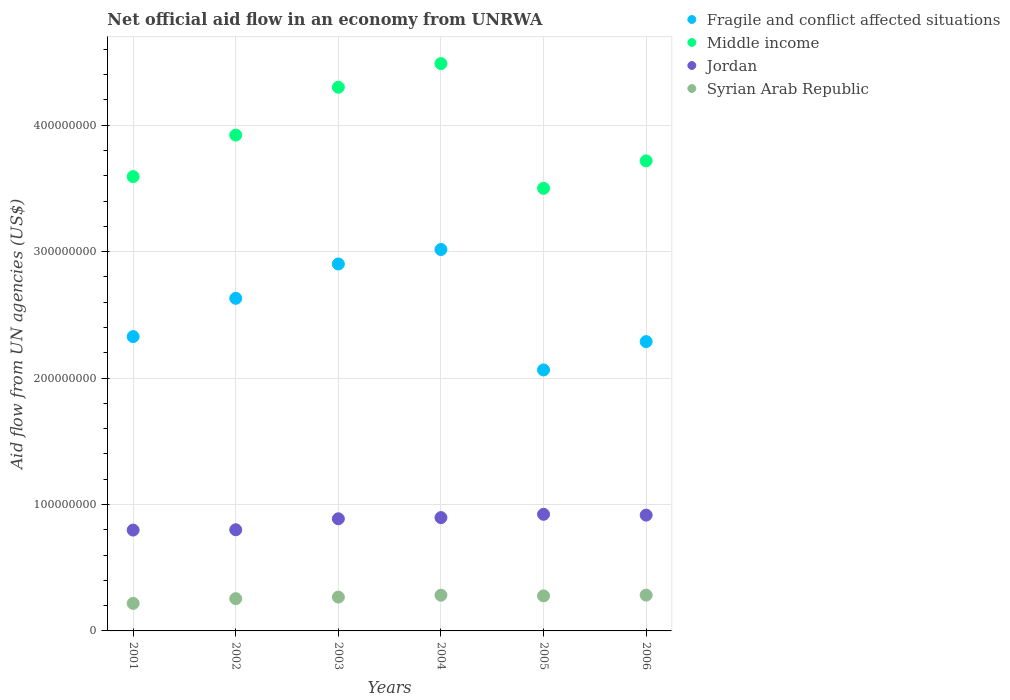How many different coloured dotlines are there?
Give a very brief answer. 4. Is the number of dotlines equal to the number of legend labels?
Give a very brief answer. Yes. What is the net official aid flow in Fragile and conflict affected situations in 2006?
Keep it short and to the point. 2.29e+08. Across all years, what is the maximum net official aid flow in Jordan?
Provide a short and direct response. 9.22e+07. Across all years, what is the minimum net official aid flow in Middle income?
Provide a succinct answer. 3.50e+08. What is the total net official aid flow in Fragile and conflict affected situations in the graph?
Offer a very short reply. 1.52e+09. What is the difference between the net official aid flow in Jordan in 2002 and that in 2006?
Offer a terse response. -1.16e+07. What is the difference between the net official aid flow in Syrian Arab Republic in 2004 and the net official aid flow in Jordan in 2005?
Offer a very short reply. -6.40e+07. What is the average net official aid flow in Fragile and conflict affected situations per year?
Make the answer very short. 2.54e+08. In the year 2004, what is the difference between the net official aid flow in Fragile and conflict affected situations and net official aid flow in Syrian Arab Republic?
Provide a short and direct response. 2.73e+08. In how many years, is the net official aid flow in Fragile and conflict affected situations greater than 180000000 US$?
Provide a short and direct response. 6. What is the ratio of the net official aid flow in Fragile and conflict affected situations in 2001 to that in 2003?
Offer a terse response. 0.8. Is the difference between the net official aid flow in Fragile and conflict affected situations in 2005 and 2006 greater than the difference between the net official aid flow in Syrian Arab Republic in 2005 and 2006?
Give a very brief answer. No. What is the difference between the highest and the second highest net official aid flow in Fragile and conflict affected situations?
Offer a very short reply. 1.15e+07. What is the difference between the highest and the lowest net official aid flow in Fragile and conflict affected situations?
Offer a terse response. 9.53e+07. In how many years, is the net official aid flow in Fragile and conflict affected situations greater than the average net official aid flow in Fragile and conflict affected situations taken over all years?
Your answer should be very brief. 3. Is the sum of the net official aid flow in Syrian Arab Republic in 2004 and 2006 greater than the maximum net official aid flow in Jordan across all years?
Keep it short and to the point. No. Is it the case that in every year, the sum of the net official aid flow in Syrian Arab Republic and net official aid flow in Fragile and conflict affected situations  is greater than the sum of net official aid flow in Jordan and net official aid flow in Middle income?
Provide a succinct answer. Yes. Does the net official aid flow in Middle income monotonically increase over the years?
Give a very brief answer. No. Is the net official aid flow in Syrian Arab Republic strictly less than the net official aid flow in Jordan over the years?
Provide a short and direct response. Yes. How many dotlines are there?
Make the answer very short. 4. How many years are there in the graph?
Offer a very short reply. 6. What is the difference between two consecutive major ticks on the Y-axis?
Keep it short and to the point. 1.00e+08. Are the values on the major ticks of Y-axis written in scientific E-notation?
Your answer should be very brief. No. Does the graph contain any zero values?
Ensure brevity in your answer.  No. Does the graph contain grids?
Keep it short and to the point. Yes. How are the legend labels stacked?
Your response must be concise. Vertical. What is the title of the graph?
Make the answer very short. Net official aid flow in an economy from UNRWA. Does "Northern Mariana Islands" appear as one of the legend labels in the graph?
Give a very brief answer. No. What is the label or title of the Y-axis?
Your answer should be compact. Aid flow from UN agencies (US$). What is the Aid flow from UN agencies (US$) of Fragile and conflict affected situations in 2001?
Give a very brief answer. 2.33e+08. What is the Aid flow from UN agencies (US$) of Middle income in 2001?
Ensure brevity in your answer.  3.59e+08. What is the Aid flow from UN agencies (US$) in Jordan in 2001?
Give a very brief answer. 7.98e+07. What is the Aid flow from UN agencies (US$) of Syrian Arab Republic in 2001?
Your response must be concise. 2.18e+07. What is the Aid flow from UN agencies (US$) of Fragile and conflict affected situations in 2002?
Give a very brief answer. 2.63e+08. What is the Aid flow from UN agencies (US$) in Middle income in 2002?
Your answer should be very brief. 3.92e+08. What is the Aid flow from UN agencies (US$) of Jordan in 2002?
Make the answer very short. 8.00e+07. What is the Aid flow from UN agencies (US$) of Syrian Arab Republic in 2002?
Ensure brevity in your answer.  2.55e+07. What is the Aid flow from UN agencies (US$) in Fragile and conflict affected situations in 2003?
Keep it short and to the point. 2.90e+08. What is the Aid flow from UN agencies (US$) in Middle income in 2003?
Provide a succinct answer. 4.30e+08. What is the Aid flow from UN agencies (US$) in Jordan in 2003?
Your response must be concise. 8.87e+07. What is the Aid flow from UN agencies (US$) in Syrian Arab Republic in 2003?
Make the answer very short. 2.68e+07. What is the Aid flow from UN agencies (US$) of Fragile and conflict affected situations in 2004?
Your answer should be very brief. 3.02e+08. What is the Aid flow from UN agencies (US$) in Middle income in 2004?
Give a very brief answer. 4.49e+08. What is the Aid flow from UN agencies (US$) of Jordan in 2004?
Make the answer very short. 8.96e+07. What is the Aid flow from UN agencies (US$) in Syrian Arab Republic in 2004?
Offer a very short reply. 2.83e+07. What is the Aid flow from UN agencies (US$) in Fragile and conflict affected situations in 2005?
Your answer should be very brief. 2.06e+08. What is the Aid flow from UN agencies (US$) in Middle income in 2005?
Offer a very short reply. 3.50e+08. What is the Aid flow from UN agencies (US$) in Jordan in 2005?
Provide a short and direct response. 9.22e+07. What is the Aid flow from UN agencies (US$) in Syrian Arab Republic in 2005?
Provide a succinct answer. 2.77e+07. What is the Aid flow from UN agencies (US$) of Fragile and conflict affected situations in 2006?
Your answer should be very brief. 2.29e+08. What is the Aid flow from UN agencies (US$) in Middle income in 2006?
Your answer should be compact. 3.72e+08. What is the Aid flow from UN agencies (US$) of Jordan in 2006?
Make the answer very short. 9.16e+07. What is the Aid flow from UN agencies (US$) in Syrian Arab Republic in 2006?
Offer a very short reply. 2.83e+07. Across all years, what is the maximum Aid flow from UN agencies (US$) in Fragile and conflict affected situations?
Make the answer very short. 3.02e+08. Across all years, what is the maximum Aid flow from UN agencies (US$) in Middle income?
Make the answer very short. 4.49e+08. Across all years, what is the maximum Aid flow from UN agencies (US$) in Jordan?
Give a very brief answer. 9.22e+07. Across all years, what is the maximum Aid flow from UN agencies (US$) in Syrian Arab Republic?
Make the answer very short. 2.83e+07. Across all years, what is the minimum Aid flow from UN agencies (US$) in Fragile and conflict affected situations?
Ensure brevity in your answer.  2.06e+08. Across all years, what is the minimum Aid flow from UN agencies (US$) of Middle income?
Offer a terse response. 3.50e+08. Across all years, what is the minimum Aid flow from UN agencies (US$) in Jordan?
Ensure brevity in your answer.  7.98e+07. Across all years, what is the minimum Aid flow from UN agencies (US$) of Syrian Arab Republic?
Ensure brevity in your answer.  2.18e+07. What is the total Aid flow from UN agencies (US$) of Fragile and conflict affected situations in the graph?
Provide a succinct answer. 1.52e+09. What is the total Aid flow from UN agencies (US$) of Middle income in the graph?
Give a very brief answer. 2.35e+09. What is the total Aid flow from UN agencies (US$) in Jordan in the graph?
Your answer should be very brief. 5.22e+08. What is the total Aid flow from UN agencies (US$) of Syrian Arab Republic in the graph?
Ensure brevity in your answer.  1.58e+08. What is the difference between the Aid flow from UN agencies (US$) of Fragile and conflict affected situations in 2001 and that in 2002?
Your answer should be very brief. -3.03e+07. What is the difference between the Aid flow from UN agencies (US$) of Middle income in 2001 and that in 2002?
Offer a terse response. -3.28e+07. What is the difference between the Aid flow from UN agencies (US$) in Syrian Arab Republic in 2001 and that in 2002?
Offer a terse response. -3.75e+06. What is the difference between the Aid flow from UN agencies (US$) in Fragile and conflict affected situations in 2001 and that in 2003?
Keep it short and to the point. -5.74e+07. What is the difference between the Aid flow from UN agencies (US$) of Middle income in 2001 and that in 2003?
Make the answer very short. -7.07e+07. What is the difference between the Aid flow from UN agencies (US$) of Jordan in 2001 and that in 2003?
Your answer should be very brief. -8.93e+06. What is the difference between the Aid flow from UN agencies (US$) in Syrian Arab Republic in 2001 and that in 2003?
Provide a short and direct response. -4.99e+06. What is the difference between the Aid flow from UN agencies (US$) of Fragile and conflict affected situations in 2001 and that in 2004?
Offer a terse response. -6.89e+07. What is the difference between the Aid flow from UN agencies (US$) in Middle income in 2001 and that in 2004?
Provide a succinct answer. -8.94e+07. What is the difference between the Aid flow from UN agencies (US$) in Jordan in 2001 and that in 2004?
Your response must be concise. -9.87e+06. What is the difference between the Aid flow from UN agencies (US$) of Syrian Arab Republic in 2001 and that in 2004?
Provide a short and direct response. -6.48e+06. What is the difference between the Aid flow from UN agencies (US$) in Fragile and conflict affected situations in 2001 and that in 2005?
Your response must be concise. 2.64e+07. What is the difference between the Aid flow from UN agencies (US$) in Middle income in 2001 and that in 2005?
Ensure brevity in your answer.  9.26e+06. What is the difference between the Aid flow from UN agencies (US$) in Jordan in 2001 and that in 2005?
Give a very brief answer. -1.25e+07. What is the difference between the Aid flow from UN agencies (US$) of Syrian Arab Republic in 2001 and that in 2005?
Your response must be concise. -5.93e+06. What is the difference between the Aid flow from UN agencies (US$) in Fragile and conflict affected situations in 2001 and that in 2006?
Offer a terse response. 3.96e+06. What is the difference between the Aid flow from UN agencies (US$) of Middle income in 2001 and that in 2006?
Your response must be concise. -1.24e+07. What is the difference between the Aid flow from UN agencies (US$) of Jordan in 2001 and that in 2006?
Keep it short and to the point. -1.18e+07. What is the difference between the Aid flow from UN agencies (US$) of Syrian Arab Republic in 2001 and that in 2006?
Your answer should be very brief. -6.54e+06. What is the difference between the Aid flow from UN agencies (US$) of Fragile and conflict affected situations in 2002 and that in 2003?
Your response must be concise. -2.72e+07. What is the difference between the Aid flow from UN agencies (US$) in Middle income in 2002 and that in 2003?
Keep it short and to the point. -3.79e+07. What is the difference between the Aid flow from UN agencies (US$) of Jordan in 2002 and that in 2003?
Keep it short and to the point. -8.69e+06. What is the difference between the Aid flow from UN agencies (US$) of Syrian Arab Republic in 2002 and that in 2003?
Offer a very short reply. -1.24e+06. What is the difference between the Aid flow from UN agencies (US$) in Fragile and conflict affected situations in 2002 and that in 2004?
Offer a terse response. -3.86e+07. What is the difference between the Aid flow from UN agencies (US$) of Middle income in 2002 and that in 2004?
Provide a short and direct response. -5.66e+07. What is the difference between the Aid flow from UN agencies (US$) in Jordan in 2002 and that in 2004?
Your answer should be compact. -9.63e+06. What is the difference between the Aid flow from UN agencies (US$) of Syrian Arab Republic in 2002 and that in 2004?
Offer a terse response. -2.73e+06. What is the difference between the Aid flow from UN agencies (US$) in Fragile and conflict affected situations in 2002 and that in 2005?
Make the answer very short. 5.67e+07. What is the difference between the Aid flow from UN agencies (US$) of Middle income in 2002 and that in 2005?
Offer a very short reply. 4.21e+07. What is the difference between the Aid flow from UN agencies (US$) of Jordan in 2002 and that in 2005?
Offer a very short reply. -1.22e+07. What is the difference between the Aid flow from UN agencies (US$) in Syrian Arab Republic in 2002 and that in 2005?
Offer a terse response. -2.18e+06. What is the difference between the Aid flow from UN agencies (US$) in Fragile and conflict affected situations in 2002 and that in 2006?
Give a very brief answer. 3.42e+07. What is the difference between the Aid flow from UN agencies (US$) in Middle income in 2002 and that in 2006?
Keep it short and to the point. 2.04e+07. What is the difference between the Aid flow from UN agencies (US$) in Jordan in 2002 and that in 2006?
Your response must be concise. -1.16e+07. What is the difference between the Aid flow from UN agencies (US$) in Syrian Arab Republic in 2002 and that in 2006?
Give a very brief answer. -2.79e+06. What is the difference between the Aid flow from UN agencies (US$) of Fragile and conflict affected situations in 2003 and that in 2004?
Give a very brief answer. -1.15e+07. What is the difference between the Aid flow from UN agencies (US$) in Middle income in 2003 and that in 2004?
Provide a succinct answer. -1.87e+07. What is the difference between the Aid flow from UN agencies (US$) of Jordan in 2003 and that in 2004?
Provide a succinct answer. -9.40e+05. What is the difference between the Aid flow from UN agencies (US$) of Syrian Arab Republic in 2003 and that in 2004?
Ensure brevity in your answer.  -1.49e+06. What is the difference between the Aid flow from UN agencies (US$) of Fragile and conflict affected situations in 2003 and that in 2005?
Provide a succinct answer. 8.38e+07. What is the difference between the Aid flow from UN agencies (US$) of Middle income in 2003 and that in 2005?
Offer a very short reply. 8.00e+07. What is the difference between the Aid flow from UN agencies (US$) in Jordan in 2003 and that in 2005?
Make the answer very short. -3.55e+06. What is the difference between the Aid flow from UN agencies (US$) in Syrian Arab Republic in 2003 and that in 2005?
Keep it short and to the point. -9.40e+05. What is the difference between the Aid flow from UN agencies (US$) of Fragile and conflict affected situations in 2003 and that in 2006?
Provide a short and direct response. 6.14e+07. What is the difference between the Aid flow from UN agencies (US$) in Middle income in 2003 and that in 2006?
Keep it short and to the point. 5.82e+07. What is the difference between the Aid flow from UN agencies (US$) in Jordan in 2003 and that in 2006?
Give a very brief answer. -2.90e+06. What is the difference between the Aid flow from UN agencies (US$) in Syrian Arab Republic in 2003 and that in 2006?
Your response must be concise. -1.55e+06. What is the difference between the Aid flow from UN agencies (US$) of Fragile and conflict affected situations in 2004 and that in 2005?
Provide a short and direct response. 9.53e+07. What is the difference between the Aid flow from UN agencies (US$) of Middle income in 2004 and that in 2005?
Your answer should be compact. 9.87e+07. What is the difference between the Aid flow from UN agencies (US$) in Jordan in 2004 and that in 2005?
Your answer should be very brief. -2.61e+06. What is the difference between the Aid flow from UN agencies (US$) of Syrian Arab Republic in 2004 and that in 2005?
Your response must be concise. 5.50e+05. What is the difference between the Aid flow from UN agencies (US$) of Fragile and conflict affected situations in 2004 and that in 2006?
Ensure brevity in your answer.  7.29e+07. What is the difference between the Aid flow from UN agencies (US$) in Middle income in 2004 and that in 2006?
Ensure brevity in your answer.  7.70e+07. What is the difference between the Aid flow from UN agencies (US$) in Jordan in 2004 and that in 2006?
Your answer should be compact. -1.96e+06. What is the difference between the Aid flow from UN agencies (US$) in Fragile and conflict affected situations in 2005 and that in 2006?
Give a very brief answer. -2.24e+07. What is the difference between the Aid flow from UN agencies (US$) of Middle income in 2005 and that in 2006?
Provide a short and direct response. -2.17e+07. What is the difference between the Aid flow from UN agencies (US$) in Jordan in 2005 and that in 2006?
Provide a short and direct response. 6.50e+05. What is the difference between the Aid flow from UN agencies (US$) of Syrian Arab Republic in 2005 and that in 2006?
Offer a very short reply. -6.10e+05. What is the difference between the Aid flow from UN agencies (US$) in Fragile and conflict affected situations in 2001 and the Aid flow from UN agencies (US$) in Middle income in 2002?
Your response must be concise. -1.59e+08. What is the difference between the Aid flow from UN agencies (US$) of Fragile and conflict affected situations in 2001 and the Aid flow from UN agencies (US$) of Jordan in 2002?
Give a very brief answer. 1.53e+08. What is the difference between the Aid flow from UN agencies (US$) in Fragile and conflict affected situations in 2001 and the Aid flow from UN agencies (US$) in Syrian Arab Republic in 2002?
Your answer should be very brief. 2.07e+08. What is the difference between the Aid flow from UN agencies (US$) of Middle income in 2001 and the Aid flow from UN agencies (US$) of Jordan in 2002?
Your response must be concise. 2.79e+08. What is the difference between the Aid flow from UN agencies (US$) of Middle income in 2001 and the Aid flow from UN agencies (US$) of Syrian Arab Republic in 2002?
Your answer should be compact. 3.34e+08. What is the difference between the Aid flow from UN agencies (US$) of Jordan in 2001 and the Aid flow from UN agencies (US$) of Syrian Arab Republic in 2002?
Provide a short and direct response. 5.42e+07. What is the difference between the Aid flow from UN agencies (US$) of Fragile and conflict affected situations in 2001 and the Aid flow from UN agencies (US$) of Middle income in 2003?
Your response must be concise. -1.97e+08. What is the difference between the Aid flow from UN agencies (US$) of Fragile and conflict affected situations in 2001 and the Aid flow from UN agencies (US$) of Jordan in 2003?
Offer a very short reply. 1.44e+08. What is the difference between the Aid flow from UN agencies (US$) of Fragile and conflict affected situations in 2001 and the Aid flow from UN agencies (US$) of Syrian Arab Republic in 2003?
Give a very brief answer. 2.06e+08. What is the difference between the Aid flow from UN agencies (US$) of Middle income in 2001 and the Aid flow from UN agencies (US$) of Jordan in 2003?
Offer a very short reply. 2.71e+08. What is the difference between the Aid flow from UN agencies (US$) of Middle income in 2001 and the Aid flow from UN agencies (US$) of Syrian Arab Republic in 2003?
Provide a short and direct response. 3.33e+08. What is the difference between the Aid flow from UN agencies (US$) of Jordan in 2001 and the Aid flow from UN agencies (US$) of Syrian Arab Republic in 2003?
Ensure brevity in your answer.  5.30e+07. What is the difference between the Aid flow from UN agencies (US$) in Fragile and conflict affected situations in 2001 and the Aid flow from UN agencies (US$) in Middle income in 2004?
Offer a very short reply. -2.16e+08. What is the difference between the Aid flow from UN agencies (US$) of Fragile and conflict affected situations in 2001 and the Aid flow from UN agencies (US$) of Jordan in 2004?
Your response must be concise. 1.43e+08. What is the difference between the Aid flow from UN agencies (US$) in Fragile and conflict affected situations in 2001 and the Aid flow from UN agencies (US$) in Syrian Arab Republic in 2004?
Make the answer very short. 2.05e+08. What is the difference between the Aid flow from UN agencies (US$) in Middle income in 2001 and the Aid flow from UN agencies (US$) in Jordan in 2004?
Provide a short and direct response. 2.70e+08. What is the difference between the Aid flow from UN agencies (US$) of Middle income in 2001 and the Aid flow from UN agencies (US$) of Syrian Arab Republic in 2004?
Offer a terse response. 3.31e+08. What is the difference between the Aid flow from UN agencies (US$) of Jordan in 2001 and the Aid flow from UN agencies (US$) of Syrian Arab Republic in 2004?
Offer a very short reply. 5.15e+07. What is the difference between the Aid flow from UN agencies (US$) of Fragile and conflict affected situations in 2001 and the Aid flow from UN agencies (US$) of Middle income in 2005?
Ensure brevity in your answer.  -1.17e+08. What is the difference between the Aid flow from UN agencies (US$) of Fragile and conflict affected situations in 2001 and the Aid flow from UN agencies (US$) of Jordan in 2005?
Your answer should be very brief. 1.41e+08. What is the difference between the Aid flow from UN agencies (US$) of Fragile and conflict affected situations in 2001 and the Aid flow from UN agencies (US$) of Syrian Arab Republic in 2005?
Keep it short and to the point. 2.05e+08. What is the difference between the Aid flow from UN agencies (US$) of Middle income in 2001 and the Aid flow from UN agencies (US$) of Jordan in 2005?
Provide a short and direct response. 2.67e+08. What is the difference between the Aid flow from UN agencies (US$) in Middle income in 2001 and the Aid flow from UN agencies (US$) in Syrian Arab Republic in 2005?
Your response must be concise. 3.32e+08. What is the difference between the Aid flow from UN agencies (US$) of Jordan in 2001 and the Aid flow from UN agencies (US$) of Syrian Arab Republic in 2005?
Make the answer very short. 5.21e+07. What is the difference between the Aid flow from UN agencies (US$) of Fragile and conflict affected situations in 2001 and the Aid flow from UN agencies (US$) of Middle income in 2006?
Offer a terse response. -1.39e+08. What is the difference between the Aid flow from UN agencies (US$) of Fragile and conflict affected situations in 2001 and the Aid flow from UN agencies (US$) of Jordan in 2006?
Offer a terse response. 1.41e+08. What is the difference between the Aid flow from UN agencies (US$) in Fragile and conflict affected situations in 2001 and the Aid flow from UN agencies (US$) in Syrian Arab Republic in 2006?
Provide a short and direct response. 2.04e+08. What is the difference between the Aid flow from UN agencies (US$) of Middle income in 2001 and the Aid flow from UN agencies (US$) of Jordan in 2006?
Make the answer very short. 2.68e+08. What is the difference between the Aid flow from UN agencies (US$) in Middle income in 2001 and the Aid flow from UN agencies (US$) in Syrian Arab Republic in 2006?
Your answer should be compact. 3.31e+08. What is the difference between the Aid flow from UN agencies (US$) of Jordan in 2001 and the Aid flow from UN agencies (US$) of Syrian Arab Republic in 2006?
Your answer should be very brief. 5.14e+07. What is the difference between the Aid flow from UN agencies (US$) in Fragile and conflict affected situations in 2002 and the Aid flow from UN agencies (US$) in Middle income in 2003?
Offer a terse response. -1.67e+08. What is the difference between the Aid flow from UN agencies (US$) in Fragile and conflict affected situations in 2002 and the Aid flow from UN agencies (US$) in Jordan in 2003?
Offer a very short reply. 1.74e+08. What is the difference between the Aid flow from UN agencies (US$) in Fragile and conflict affected situations in 2002 and the Aid flow from UN agencies (US$) in Syrian Arab Republic in 2003?
Offer a terse response. 2.36e+08. What is the difference between the Aid flow from UN agencies (US$) in Middle income in 2002 and the Aid flow from UN agencies (US$) in Jordan in 2003?
Ensure brevity in your answer.  3.04e+08. What is the difference between the Aid flow from UN agencies (US$) in Middle income in 2002 and the Aid flow from UN agencies (US$) in Syrian Arab Republic in 2003?
Provide a succinct answer. 3.65e+08. What is the difference between the Aid flow from UN agencies (US$) of Jordan in 2002 and the Aid flow from UN agencies (US$) of Syrian Arab Republic in 2003?
Make the answer very short. 5.32e+07. What is the difference between the Aid flow from UN agencies (US$) in Fragile and conflict affected situations in 2002 and the Aid flow from UN agencies (US$) in Middle income in 2004?
Give a very brief answer. -1.86e+08. What is the difference between the Aid flow from UN agencies (US$) of Fragile and conflict affected situations in 2002 and the Aid flow from UN agencies (US$) of Jordan in 2004?
Ensure brevity in your answer.  1.73e+08. What is the difference between the Aid flow from UN agencies (US$) in Fragile and conflict affected situations in 2002 and the Aid flow from UN agencies (US$) in Syrian Arab Republic in 2004?
Offer a terse response. 2.35e+08. What is the difference between the Aid flow from UN agencies (US$) in Middle income in 2002 and the Aid flow from UN agencies (US$) in Jordan in 2004?
Your response must be concise. 3.03e+08. What is the difference between the Aid flow from UN agencies (US$) in Middle income in 2002 and the Aid flow from UN agencies (US$) in Syrian Arab Republic in 2004?
Keep it short and to the point. 3.64e+08. What is the difference between the Aid flow from UN agencies (US$) in Jordan in 2002 and the Aid flow from UN agencies (US$) in Syrian Arab Republic in 2004?
Ensure brevity in your answer.  5.18e+07. What is the difference between the Aid flow from UN agencies (US$) in Fragile and conflict affected situations in 2002 and the Aid flow from UN agencies (US$) in Middle income in 2005?
Provide a short and direct response. -8.70e+07. What is the difference between the Aid flow from UN agencies (US$) in Fragile and conflict affected situations in 2002 and the Aid flow from UN agencies (US$) in Jordan in 2005?
Offer a very short reply. 1.71e+08. What is the difference between the Aid flow from UN agencies (US$) in Fragile and conflict affected situations in 2002 and the Aid flow from UN agencies (US$) in Syrian Arab Republic in 2005?
Ensure brevity in your answer.  2.35e+08. What is the difference between the Aid flow from UN agencies (US$) in Middle income in 2002 and the Aid flow from UN agencies (US$) in Jordan in 2005?
Give a very brief answer. 3.00e+08. What is the difference between the Aid flow from UN agencies (US$) in Middle income in 2002 and the Aid flow from UN agencies (US$) in Syrian Arab Republic in 2005?
Offer a terse response. 3.64e+08. What is the difference between the Aid flow from UN agencies (US$) in Jordan in 2002 and the Aid flow from UN agencies (US$) in Syrian Arab Republic in 2005?
Your answer should be very brief. 5.23e+07. What is the difference between the Aid flow from UN agencies (US$) in Fragile and conflict affected situations in 2002 and the Aid flow from UN agencies (US$) in Middle income in 2006?
Offer a terse response. -1.09e+08. What is the difference between the Aid flow from UN agencies (US$) of Fragile and conflict affected situations in 2002 and the Aid flow from UN agencies (US$) of Jordan in 2006?
Your answer should be very brief. 1.72e+08. What is the difference between the Aid flow from UN agencies (US$) of Fragile and conflict affected situations in 2002 and the Aid flow from UN agencies (US$) of Syrian Arab Republic in 2006?
Provide a succinct answer. 2.35e+08. What is the difference between the Aid flow from UN agencies (US$) in Middle income in 2002 and the Aid flow from UN agencies (US$) in Jordan in 2006?
Offer a very short reply. 3.01e+08. What is the difference between the Aid flow from UN agencies (US$) of Middle income in 2002 and the Aid flow from UN agencies (US$) of Syrian Arab Republic in 2006?
Your response must be concise. 3.64e+08. What is the difference between the Aid flow from UN agencies (US$) of Jordan in 2002 and the Aid flow from UN agencies (US$) of Syrian Arab Republic in 2006?
Your response must be concise. 5.17e+07. What is the difference between the Aid flow from UN agencies (US$) in Fragile and conflict affected situations in 2003 and the Aid flow from UN agencies (US$) in Middle income in 2004?
Keep it short and to the point. -1.59e+08. What is the difference between the Aid flow from UN agencies (US$) of Fragile and conflict affected situations in 2003 and the Aid flow from UN agencies (US$) of Jordan in 2004?
Keep it short and to the point. 2.01e+08. What is the difference between the Aid flow from UN agencies (US$) in Fragile and conflict affected situations in 2003 and the Aid flow from UN agencies (US$) in Syrian Arab Republic in 2004?
Ensure brevity in your answer.  2.62e+08. What is the difference between the Aid flow from UN agencies (US$) of Middle income in 2003 and the Aid flow from UN agencies (US$) of Jordan in 2004?
Make the answer very short. 3.40e+08. What is the difference between the Aid flow from UN agencies (US$) in Middle income in 2003 and the Aid flow from UN agencies (US$) in Syrian Arab Republic in 2004?
Offer a very short reply. 4.02e+08. What is the difference between the Aid flow from UN agencies (US$) in Jordan in 2003 and the Aid flow from UN agencies (US$) in Syrian Arab Republic in 2004?
Provide a succinct answer. 6.04e+07. What is the difference between the Aid flow from UN agencies (US$) in Fragile and conflict affected situations in 2003 and the Aid flow from UN agencies (US$) in Middle income in 2005?
Your answer should be compact. -5.99e+07. What is the difference between the Aid flow from UN agencies (US$) in Fragile and conflict affected situations in 2003 and the Aid flow from UN agencies (US$) in Jordan in 2005?
Provide a succinct answer. 1.98e+08. What is the difference between the Aid flow from UN agencies (US$) in Fragile and conflict affected situations in 2003 and the Aid flow from UN agencies (US$) in Syrian Arab Republic in 2005?
Provide a short and direct response. 2.63e+08. What is the difference between the Aid flow from UN agencies (US$) of Middle income in 2003 and the Aid flow from UN agencies (US$) of Jordan in 2005?
Provide a short and direct response. 3.38e+08. What is the difference between the Aid flow from UN agencies (US$) of Middle income in 2003 and the Aid flow from UN agencies (US$) of Syrian Arab Republic in 2005?
Your answer should be very brief. 4.02e+08. What is the difference between the Aid flow from UN agencies (US$) of Jordan in 2003 and the Aid flow from UN agencies (US$) of Syrian Arab Republic in 2005?
Offer a terse response. 6.10e+07. What is the difference between the Aid flow from UN agencies (US$) of Fragile and conflict affected situations in 2003 and the Aid flow from UN agencies (US$) of Middle income in 2006?
Your response must be concise. -8.16e+07. What is the difference between the Aid flow from UN agencies (US$) of Fragile and conflict affected situations in 2003 and the Aid flow from UN agencies (US$) of Jordan in 2006?
Offer a terse response. 1.99e+08. What is the difference between the Aid flow from UN agencies (US$) in Fragile and conflict affected situations in 2003 and the Aid flow from UN agencies (US$) in Syrian Arab Republic in 2006?
Ensure brevity in your answer.  2.62e+08. What is the difference between the Aid flow from UN agencies (US$) in Middle income in 2003 and the Aid flow from UN agencies (US$) in Jordan in 2006?
Your response must be concise. 3.38e+08. What is the difference between the Aid flow from UN agencies (US$) in Middle income in 2003 and the Aid flow from UN agencies (US$) in Syrian Arab Republic in 2006?
Make the answer very short. 4.02e+08. What is the difference between the Aid flow from UN agencies (US$) of Jordan in 2003 and the Aid flow from UN agencies (US$) of Syrian Arab Republic in 2006?
Give a very brief answer. 6.04e+07. What is the difference between the Aid flow from UN agencies (US$) of Fragile and conflict affected situations in 2004 and the Aid flow from UN agencies (US$) of Middle income in 2005?
Your answer should be compact. -4.84e+07. What is the difference between the Aid flow from UN agencies (US$) of Fragile and conflict affected situations in 2004 and the Aid flow from UN agencies (US$) of Jordan in 2005?
Ensure brevity in your answer.  2.09e+08. What is the difference between the Aid flow from UN agencies (US$) of Fragile and conflict affected situations in 2004 and the Aid flow from UN agencies (US$) of Syrian Arab Republic in 2005?
Provide a short and direct response. 2.74e+08. What is the difference between the Aid flow from UN agencies (US$) of Middle income in 2004 and the Aid flow from UN agencies (US$) of Jordan in 2005?
Make the answer very short. 3.57e+08. What is the difference between the Aid flow from UN agencies (US$) of Middle income in 2004 and the Aid flow from UN agencies (US$) of Syrian Arab Republic in 2005?
Your response must be concise. 4.21e+08. What is the difference between the Aid flow from UN agencies (US$) in Jordan in 2004 and the Aid flow from UN agencies (US$) in Syrian Arab Republic in 2005?
Keep it short and to the point. 6.19e+07. What is the difference between the Aid flow from UN agencies (US$) in Fragile and conflict affected situations in 2004 and the Aid flow from UN agencies (US$) in Middle income in 2006?
Your response must be concise. -7.01e+07. What is the difference between the Aid flow from UN agencies (US$) in Fragile and conflict affected situations in 2004 and the Aid flow from UN agencies (US$) in Jordan in 2006?
Provide a short and direct response. 2.10e+08. What is the difference between the Aid flow from UN agencies (US$) of Fragile and conflict affected situations in 2004 and the Aid flow from UN agencies (US$) of Syrian Arab Republic in 2006?
Your answer should be compact. 2.73e+08. What is the difference between the Aid flow from UN agencies (US$) of Middle income in 2004 and the Aid flow from UN agencies (US$) of Jordan in 2006?
Your response must be concise. 3.57e+08. What is the difference between the Aid flow from UN agencies (US$) of Middle income in 2004 and the Aid flow from UN agencies (US$) of Syrian Arab Republic in 2006?
Offer a very short reply. 4.20e+08. What is the difference between the Aid flow from UN agencies (US$) in Jordan in 2004 and the Aid flow from UN agencies (US$) in Syrian Arab Republic in 2006?
Keep it short and to the point. 6.13e+07. What is the difference between the Aid flow from UN agencies (US$) in Fragile and conflict affected situations in 2005 and the Aid flow from UN agencies (US$) in Middle income in 2006?
Offer a very short reply. -1.65e+08. What is the difference between the Aid flow from UN agencies (US$) in Fragile and conflict affected situations in 2005 and the Aid flow from UN agencies (US$) in Jordan in 2006?
Make the answer very short. 1.15e+08. What is the difference between the Aid flow from UN agencies (US$) in Fragile and conflict affected situations in 2005 and the Aid flow from UN agencies (US$) in Syrian Arab Republic in 2006?
Your answer should be compact. 1.78e+08. What is the difference between the Aid flow from UN agencies (US$) in Middle income in 2005 and the Aid flow from UN agencies (US$) in Jordan in 2006?
Provide a succinct answer. 2.59e+08. What is the difference between the Aid flow from UN agencies (US$) in Middle income in 2005 and the Aid flow from UN agencies (US$) in Syrian Arab Republic in 2006?
Make the answer very short. 3.22e+08. What is the difference between the Aid flow from UN agencies (US$) in Jordan in 2005 and the Aid flow from UN agencies (US$) in Syrian Arab Republic in 2006?
Give a very brief answer. 6.39e+07. What is the average Aid flow from UN agencies (US$) of Fragile and conflict affected situations per year?
Make the answer very short. 2.54e+08. What is the average Aid flow from UN agencies (US$) in Middle income per year?
Provide a succinct answer. 3.92e+08. What is the average Aid flow from UN agencies (US$) of Jordan per year?
Offer a very short reply. 8.70e+07. What is the average Aid flow from UN agencies (US$) of Syrian Arab Republic per year?
Offer a very short reply. 2.64e+07. In the year 2001, what is the difference between the Aid flow from UN agencies (US$) of Fragile and conflict affected situations and Aid flow from UN agencies (US$) of Middle income?
Offer a very short reply. -1.27e+08. In the year 2001, what is the difference between the Aid flow from UN agencies (US$) in Fragile and conflict affected situations and Aid flow from UN agencies (US$) in Jordan?
Provide a short and direct response. 1.53e+08. In the year 2001, what is the difference between the Aid flow from UN agencies (US$) in Fragile and conflict affected situations and Aid flow from UN agencies (US$) in Syrian Arab Republic?
Provide a succinct answer. 2.11e+08. In the year 2001, what is the difference between the Aid flow from UN agencies (US$) in Middle income and Aid flow from UN agencies (US$) in Jordan?
Provide a succinct answer. 2.80e+08. In the year 2001, what is the difference between the Aid flow from UN agencies (US$) in Middle income and Aid flow from UN agencies (US$) in Syrian Arab Republic?
Ensure brevity in your answer.  3.38e+08. In the year 2001, what is the difference between the Aid flow from UN agencies (US$) of Jordan and Aid flow from UN agencies (US$) of Syrian Arab Republic?
Offer a terse response. 5.80e+07. In the year 2002, what is the difference between the Aid flow from UN agencies (US$) of Fragile and conflict affected situations and Aid flow from UN agencies (US$) of Middle income?
Offer a terse response. -1.29e+08. In the year 2002, what is the difference between the Aid flow from UN agencies (US$) in Fragile and conflict affected situations and Aid flow from UN agencies (US$) in Jordan?
Ensure brevity in your answer.  1.83e+08. In the year 2002, what is the difference between the Aid flow from UN agencies (US$) in Fragile and conflict affected situations and Aid flow from UN agencies (US$) in Syrian Arab Republic?
Offer a terse response. 2.38e+08. In the year 2002, what is the difference between the Aid flow from UN agencies (US$) of Middle income and Aid flow from UN agencies (US$) of Jordan?
Offer a very short reply. 3.12e+08. In the year 2002, what is the difference between the Aid flow from UN agencies (US$) of Middle income and Aid flow from UN agencies (US$) of Syrian Arab Republic?
Provide a succinct answer. 3.67e+08. In the year 2002, what is the difference between the Aid flow from UN agencies (US$) in Jordan and Aid flow from UN agencies (US$) in Syrian Arab Republic?
Provide a succinct answer. 5.45e+07. In the year 2003, what is the difference between the Aid flow from UN agencies (US$) in Fragile and conflict affected situations and Aid flow from UN agencies (US$) in Middle income?
Your response must be concise. -1.40e+08. In the year 2003, what is the difference between the Aid flow from UN agencies (US$) of Fragile and conflict affected situations and Aid flow from UN agencies (US$) of Jordan?
Keep it short and to the point. 2.02e+08. In the year 2003, what is the difference between the Aid flow from UN agencies (US$) in Fragile and conflict affected situations and Aid flow from UN agencies (US$) in Syrian Arab Republic?
Provide a short and direct response. 2.63e+08. In the year 2003, what is the difference between the Aid flow from UN agencies (US$) of Middle income and Aid flow from UN agencies (US$) of Jordan?
Provide a succinct answer. 3.41e+08. In the year 2003, what is the difference between the Aid flow from UN agencies (US$) in Middle income and Aid flow from UN agencies (US$) in Syrian Arab Republic?
Your response must be concise. 4.03e+08. In the year 2003, what is the difference between the Aid flow from UN agencies (US$) of Jordan and Aid flow from UN agencies (US$) of Syrian Arab Republic?
Offer a very short reply. 6.19e+07. In the year 2004, what is the difference between the Aid flow from UN agencies (US$) in Fragile and conflict affected situations and Aid flow from UN agencies (US$) in Middle income?
Your answer should be very brief. -1.47e+08. In the year 2004, what is the difference between the Aid flow from UN agencies (US$) in Fragile and conflict affected situations and Aid flow from UN agencies (US$) in Jordan?
Offer a terse response. 2.12e+08. In the year 2004, what is the difference between the Aid flow from UN agencies (US$) of Fragile and conflict affected situations and Aid flow from UN agencies (US$) of Syrian Arab Republic?
Offer a terse response. 2.73e+08. In the year 2004, what is the difference between the Aid flow from UN agencies (US$) of Middle income and Aid flow from UN agencies (US$) of Jordan?
Offer a very short reply. 3.59e+08. In the year 2004, what is the difference between the Aid flow from UN agencies (US$) in Middle income and Aid flow from UN agencies (US$) in Syrian Arab Republic?
Offer a very short reply. 4.21e+08. In the year 2004, what is the difference between the Aid flow from UN agencies (US$) in Jordan and Aid flow from UN agencies (US$) in Syrian Arab Republic?
Your answer should be very brief. 6.14e+07. In the year 2005, what is the difference between the Aid flow from UN agencies (US$) in Fragile and conflict affected situations and Aid flow from UN agencies (US$) in Middle income?
Offer a terse response. -1.44e+08. In the year 2005, what is the difference between the Aid flow from UN agencies (US$) in Fragile and conflict affected situations and Aid flow from UN agencies (US$) in Jordan?
Your answer should be very brief. 1.14e+08. In the year 2005, what is the difference between the Aid flow from UN agencies (US$) in Fragile and conflict affected situations and Aid flow from UN agencies (US$) in Syrian Arab Republic?
Your answer should be compact. 1.79e+08. In the year 2005, what is the difference between the Aid flow from UN agencies (US$) in Middle income and Aid flow from UN agencies (US$) in Jordan?
Keep it short and to the point. 2.58e+08. In the year 2005, what is the difference between the Aid flow from UN agencies (US$) of Middle income and Aid flow from UN agencies (US$) of Syrian Arab Republic?
Ensure brevity in your answer.  3.22e+08. In the year 2005, what is the difference between the Aid flow from UN agencies (US$) in Jordan and Aid flow from UN agencies (US$) in Syrian Arab Republic?
Ensure brevity in your answer.  6.45e+07. In the year 2006, what is the difference between the Aid flow from UN agencies (US$) in Fragile and conflict affected situations and Aid flow from UN agencies (US$) in Middle income?
Make the answer very short. -1.43e+08. In the year 2006, what is the difference between the Aid flow from UN agencies (US$) of Fragile and conflict affected situations and Aid flow from UN agencies (US$) of Jordan?
Offer a very short reply. 1.37e+08. In the year 2006, what is the difference between the Aid flow from UN agencies (US$) of Fragile and conflict affected situations and Aid flow from UN agencies (US$) of Syrian Arab Republic?
Offer a very short reply. 2.01e+08. In the year 2006, what is the difference between the Aid flow from UN agencies (US$) of Middle income and Aid flow from UN agencies (US$) of Jordan?
Ensure brevity in your answer.  2.80e+08. In the year 2006, what is the difference between the Aid flow from UN agencies (US$) of Middle income and Aid flow from UN agencies (US$) of Syrian Arab Republic?
Your answer should be compact. 3.43e+08. In the year 2006, what is the difference between the Aid flow from UN agencies (US$) of Jordan and Aid flow from UN agencies (US$) of Syrian Arab Republic?
Your response must be concise. 6.33e+07. What is the ratio of the Aid flow from UN agencies (US$) in Fragile and conflict affected situations in 2001 to that in 2002?
Provide a succinct answer. 0.88. What is the ratio of the Aid flow from UN agencies (US$) in Middle income in 2001 to that in 2002?
Your response must be concise. 0.92. What is the ratio of the Aid flow from UN agencies (US$) of Syrian Arab Republic in 2001 to that in 2002?
Offer a terse response. 0.85. What is the ratio of the Aid flow from UN agencies (US$) of Fragile and conflict affected situations in 2001 to that in 2003?
Your answer should be compact. 0.8. What is the ratio of the Aid flow from UN agencies (US$) in Middle income in 2001 to that in 2003?
Provide a short and direct response. 0.84. What is the ratio of the Aid flow from UN agencies (US$) in Jordan in 2001 to that in 2003?
Make the answer very short. 0.9. What is the ratio of the Aid flow from UN agencies (US$) of Syrian Arab Republic in 2001 to that in 2003?
Provide a succinct answer. 0.81. What is the ratio of the Aid flow from UN agencies (US$) of Fragile and conflict affected situations in 2001 to that in 2004?
Your answer should be compact. 0.77. What is the ratio of the Aid flow from UN agencies (US$) of Middle income in 2001 to that in 2004?
Keep it short and to the point. 0.8. What is the ratio of the Aid flow from UN agencies (US$) in Jordan in 2001 to that in 2004?
Your answer should be very brief. 0.89. What is the ratio of the Aid flow from UN agencies (US$) in Syrian Arab Republic in 2001 to that in 2004?
Offer a terse response. 0.77. What is the ratio of the Aid flow from UN agencies (US$) in Fragile and conflict affected situations in 2001 to that in 2005?
Make the answer very short. 1.13. What is the ratio of the Aid flow from UN agencies (US$) of Middle income in 2001 to that in 2005?
Offer a terse response. 1.03. What is the ratio of the Aid flow from UN agencies (US$) in Jordan in 2001 to that in 2005?
Your response must be concise. 0.86. What is the ratio of the Aid flow from UN agencies (US$) of Syrian Arab Republic in 2001 to that in 2005?
Provide a succinct answer. 0.79. What is the ratio of the Aid flow from UN agencies (US$) in Fragile and conflict affected situations in 2001 to that in 2006?
Your answer should be very brief. 1.02. What is the ratio of the Aid flow from UN agencies (US$) of Middle income in 2001 to that in 2006?
Ensure brevity in your answer.  0.97. What is the ratio of the Aid flow from UN agencies (US$) of Jordan in 2001 to that in 2006?
Make the answer very short. 0.87. What is the ratio of the Aid flow from UN agencies (US$) in Syrian Arab Republic in 2001 to that in 2006?
Offer a terse response. 0.77. What is the ratio of the Aid flow from UN agencies (US$) of Fragile and conflict affected situations in 2002 to that in 2003?
Keep it short and to the point. 0.91. What is the ratio of the Aid flow from UN agencies (US$) in Middle income in 2002 to that in 2003?
Your response must be concise. 0.91. What is the ratio of the Aid flow from UN agencies (US$) in Jordan in 2002 to that in 2003?
Offer a very short reply. 0.9. What is the ratio of the Aid flow from UN agencies (US$) of Syrian Arab Republic in 2002 to that in 2003?
Keep it short and to the point. 0.95. What is the ratio of the Aid flow from UN agencies (US$) of Fragile and conflict affected situations in 2002 to that in 2004?
Ensure brevity in your answer.  0.87. What is the ratio of the Aid flow from UN agencies (US$) in Middle income in 2002 to that in 2004?
Your answer should be compact. 0.87. What is the ratio of the Aid flow from UN agencies (US$) in Jordan in 2002 to that in 2004?
Make the answer very short. 0.89. What is the ratio of the Aid flow from UN agencies (US$) in Syrian Arab Republic in 2002 to that in 2004?
Provide a succinct answer. 0.9. What is the ratio of the Aid flow from UN agencies (US$) of Fragile and conflict affected situations in 2002 to that in 2005?
Your response must be concise. 1.27. What is the ratio of the Aid flow from UN agencies (US$) in Middle income in 2002 to that in 2005?
Give a very brief answer. 1.12. What is the ratio of the Aid flow from UN agencies (US$) of Jordan in 2002 to that in 2005?
Your answer should be compact. 0.87. What is the ratio of the Aid flow from UN agencies (US$) in Syrian Arab Republic in 2002 to that in 2005?
Ensure brevity in your answer.  0.92. What is the ratio of the Aid flow from UN agencies (US$) of Fragile and conflict affected situations in 2002 to that in 2006?
Your answer should be compact. 1.15. What is the ratio of the Aid flow from UN agencies (US$) of Middle income in 2002 to that in 2006?
Offer a very short reply. 1.05. What is the ratio of the Aid flow from UN agencies (US$) in Jordan in 2002 to that in 2006?
Give a very brief answer. 0.87. What is the ratio of the Aid flow from UN agencies (US$) of Syrian Arab Republic in 2002 to that in 2006?
Provide a succinct answer. 0.9. What is the ratio of the Aid flow from UN agencies (US$) of Middle income in 2003 to that in 2004?
Give a very brief answer. 0.96. What is the ratio of the Aid flow from UN agencies (US$) of Jordan in 2003 to that in 2004?
Provide a short and direct response. 0.99. What is the ratio of the Aid flow from UN agencies (US$) in Syrian Arab Republic in 2003 to that in 2004?
Offer a terse response. 0.95. What is the ratio of the Aid flow from UN agencies (US$) in Fragile and conflict affected situations in 2003 to that in 2005?
Ensure brevity in your answer.  1.41. What is the ratio of the Aid flow from UN agencies (US$) in Middle income in 2003 to that in 2005?
Give a very brief answer. 1.23. What is the ratio of the Aid flow from UN agencies (US$) in Jordan in 2003 to that in 2005?
Keep it short and to the point. 0.96. What is the ratio of the Aid flow from UN agencies (US$) of Syrian Arab Republic in 2003 to that in 2005?
Give a very brief answer. 0.97. What is the ratio of the Aid flow from UN agencies (US$) of Fragile and conflict affected situations in 2003 to that in 2006?
Your response must be concise. 1.27. What is the ratio of the Aid flow from UN agencies (US$) in Middle income in 2003 to that in 2006?
Offer a very short reply. 1.16. What is the ratio of the Aid flow from UN agencies (US$) in Jordan in 2003 to that in 2006?
Offer a terse response. 0.97. What is the ratio of the Aid flow from UN agencies (US$) of Syrian Arab Republic in 2003 to that in 2006?
Make the answer very short. 0.95. What is the ratio of the Aid flow from UN agencies (US$) in Fragile and conflict affected situations in 2004 to that in 2005?
Offer a very short reply. 1.46. What is the ratio of the Aid flow from UN agencies (US$) of Middle income in 2004 to that in 2005?
Your response must be concise. 1.28. What is the ratio of the Aid flow from UN agencies (US$) of Jordan in 2004 to that in 2005?
Provide a succinct answer. 0.97. What is the ratio of the Aid flow from UN agencies (US$) in Syrian Arab Republic in 2004 to that in 2005?
Give a very brief answer. 1.02. What is the ratio of the Aid flow from UN agencies (US$) in Fragile and conflict affected situations in 2004 to that in 2006?
Keep it short and to the point. 1.32. What is the ratio of the Aid flow from UN agencies (US$) in Middle income in 2004 to that in 2006?
Provide a succinct answer. 1.21. What is the ratio of the Aid flow from UN agencies (US$) in Jordan in 2004 to that in 2006?
Your answer should be very brief. 0.98. What is the ratio of the Aid flow from UN agencies (US$) in Fragile and conflict affected situations in 2005 to that in 2006?
Provide a succinct answer. 0.9. What is the ratio of the Aid flow from UN agencies (US$) in Middle income in 2005 to that in 2006?
Your answer should be compact. 0.94. What is the ratio of the Aid flow from UN agencies (US$) of Jordan in 2005 to that in 2006?
Provide a short and direct response. 1.01. What is the ratio of the Aid flow from UN agencies (US$) in Syrian Arab Republic in 2005 to that in 2006?
Offer a terse response. 0.98. What is the difference between the highest and the second highest Aid flow from UN agencies (US$) of Fragile and conflict affected situations?
Your response must be concise. 1.15e+07. What is the difference between the highest and the second highest Aid flow from UN agencies (US$) of Middle income?
Your answer should be very brief. 1.87e+07. What is the difference between the highest and the second highest Aid flow from UN agencies (US$) in Jordan?
Offer a very short reply. 6.50e+05. What is the difference between the highest and the lowest Aid flow from UN agencies (US$) in Fragile and conflict affected situations?
Your answer should be very brief. 9.53e+07. What is the difference between the highest and the lowest Aid flow from UN agencies (US$) in Middle income?
Your answer should be very brief. 9.87e+07. What is the difference between the highest and the lowest Aid flow from UN agencies (US$) of Jordan?
Offer a terse response. 1.25e+07. What is the difference between the highest and the lowest Aid flow from UN agencies (US$) in Syrian Arab Republic?
Offer a very short reply. 6.54e+06. 